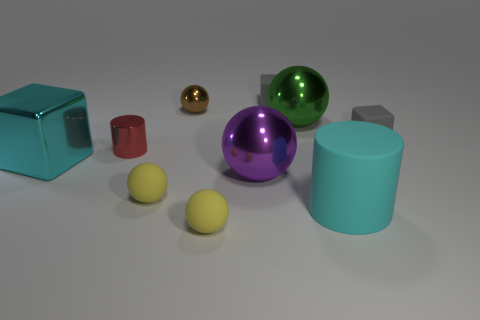Subtract 2 spheres. How many spheres are left? 3 Subtract all green spheres. How many spheres are left? 4 Subtract all large purple spheres. How many spheres are left? 4 Subtract all green spheres. Subtract all blue cubes. How many spheres are left? 4 Subtract all cylinders. How many objects are left? 8 Add 6 large things. How many large things are left? 10 Add 8 large purple metal things. How many large purple metal things exist? 9 Subtract 0 red balls. How many objects are left? 10 Subtract all tiny gray blocks. Subtract all large cubes. How many objects are left? 7 